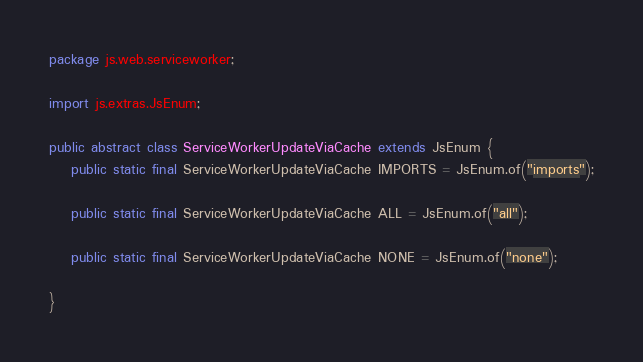<code> <loc_0><loc_0><loc_500><loc_500><_Java_>package js.web.serviceworker;

import js.extras.JsEnum;

public abstract class ServiceWorkerUpdateViaCache extends JsEnum {
    public static final ServiceWorkerUpdateViaCache IMPORTS = JsEnum.of("imports");

    public static final ServiceWorkerUpdateViaCache ALL = JsEnum.of("all");

    public static final ServiceWorkerUpdateViaCache NONE = JsEnum.of("none");

}
</code> 